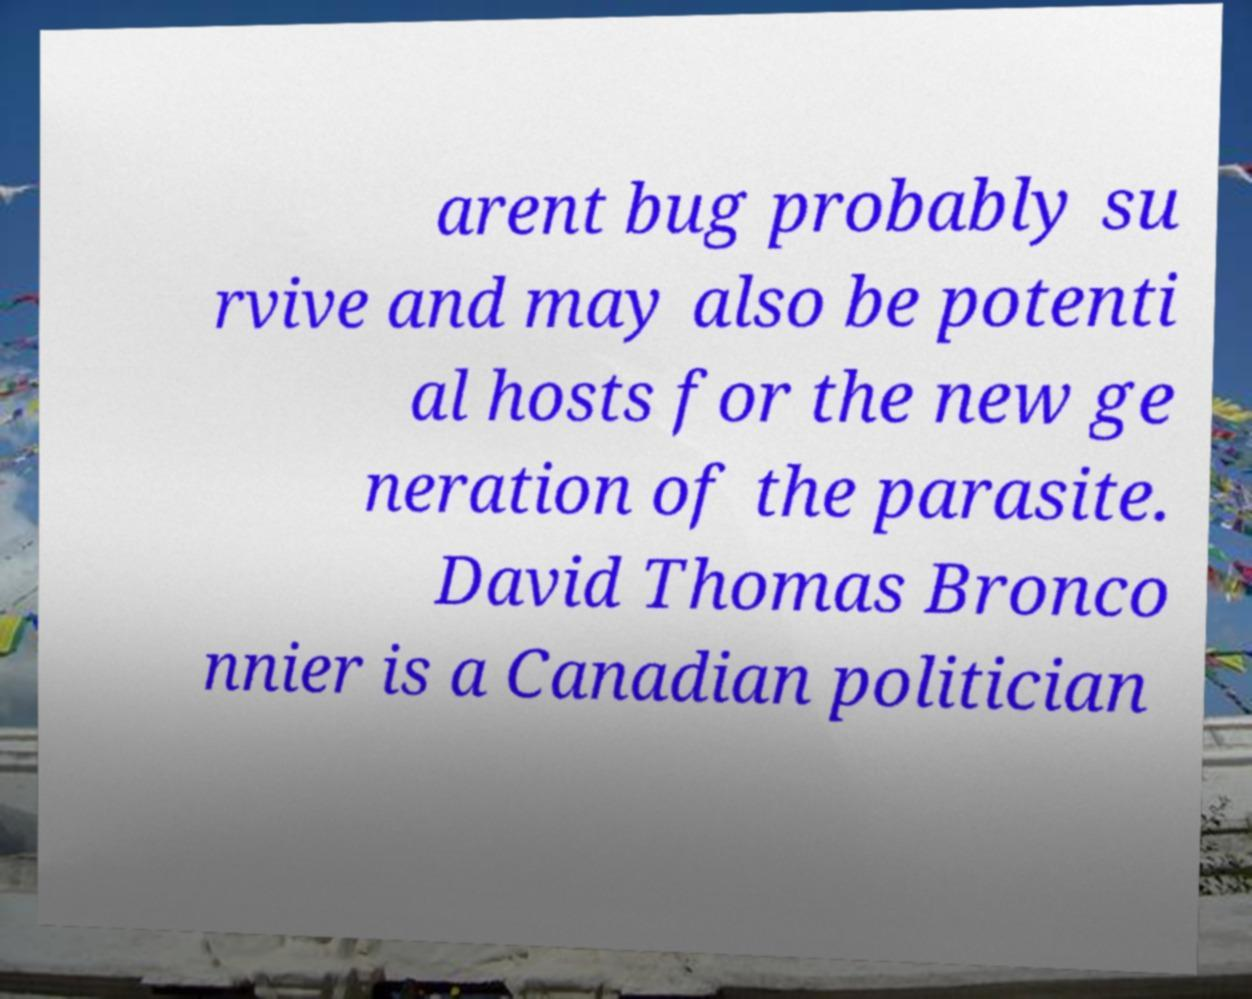For documentation purposes, I need the text within this image transcribed. Could you provide that? arent bug probably su rvive and may also be potenti al hosts for the new ge neration of the parasite. David Thomas Bronco nnier is a Canadian politician 